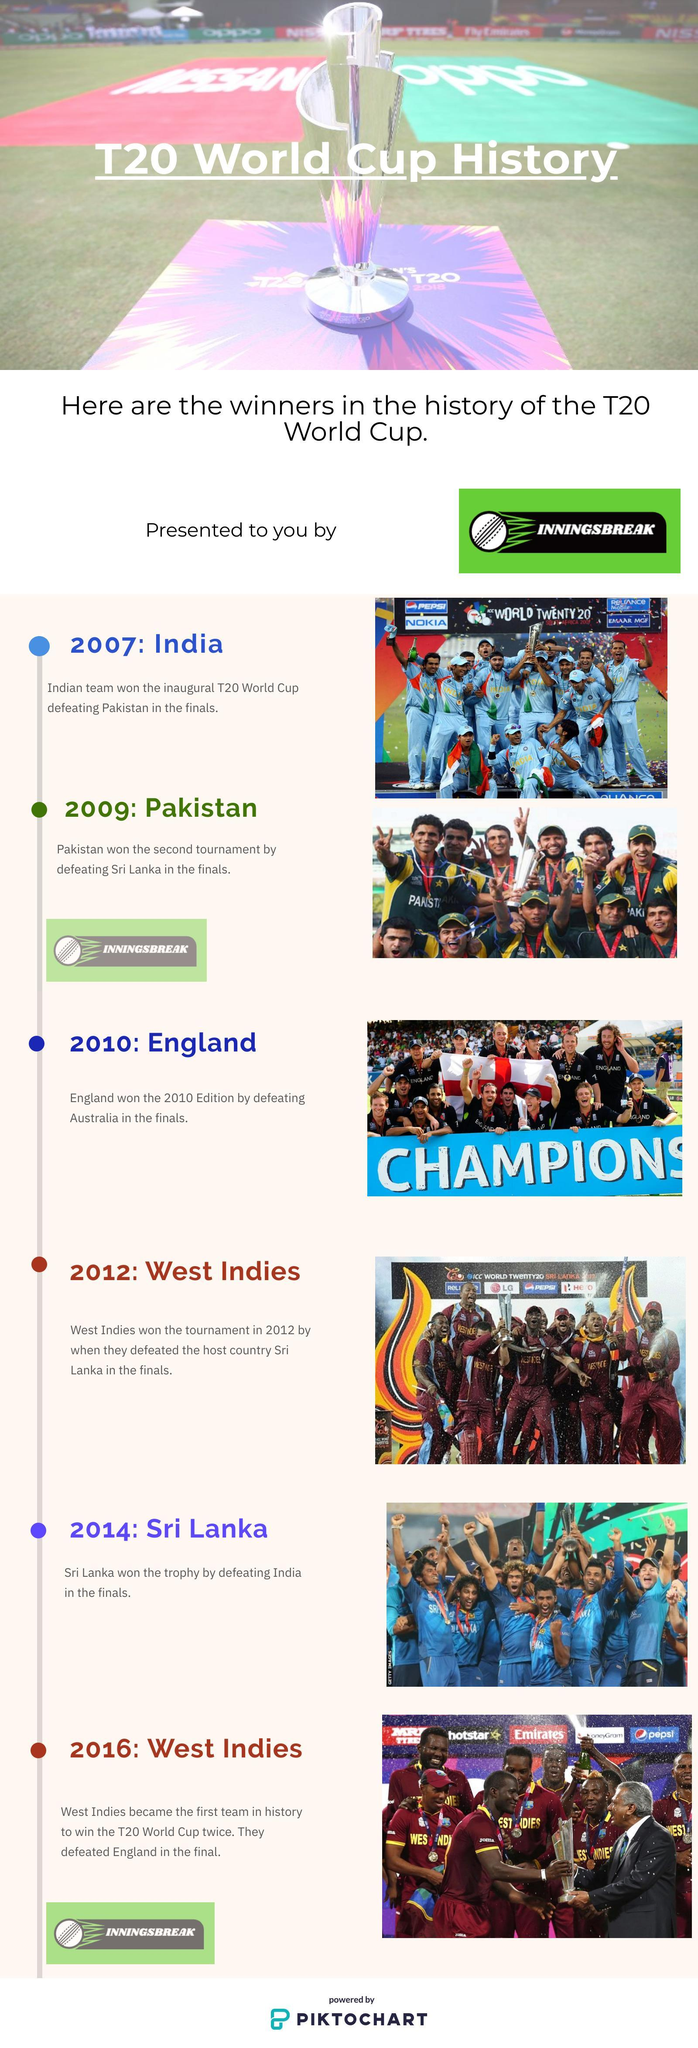which team won the T20 world cup after England?
Answer the question with a short phrase. West Indies which team won the T20 world cup after India? Pakistan which team won the inaugural T20 world cup? India How many T20 world cup tournaments have been played? 6 How many T20 world cup final matches have been played by India? 2 